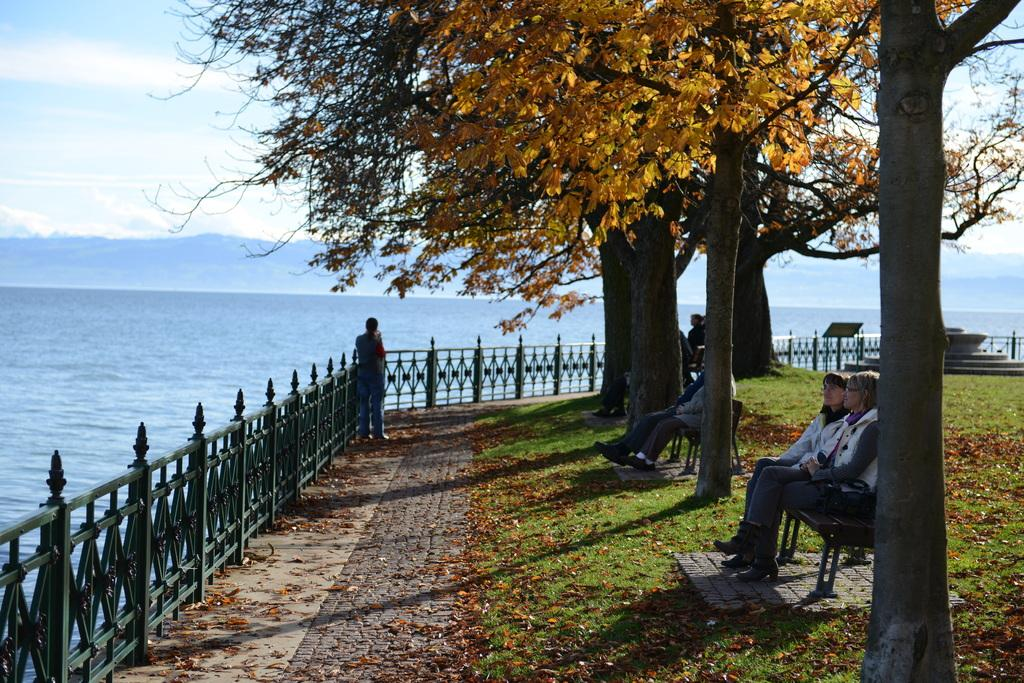How many people are in the image? There is a group of persons in the image. What are the persons doing in the image? The persons are sitting on a bench. Where is the bench located? The bench is located in a garden. What can be seen in the background of the image? There are mountains, a beach, iron grills, a tree, grass, and the sky visible in the background of the image. What is the purpose of the zebra in the image? There is no zebra present in the image. 